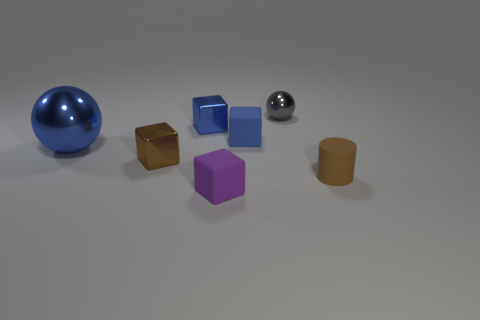There is a matte cube behind the brown matte thing; is its color the same as the big object?
Make the answer very short. Yes. Are there any other things of the same color as the tiny cylinder?
Your answer should be compact. Yes. Does the sphere that is in front of the tiny blue metal thing have the same color as the tiny block that is right of the purple matte block?
Keep it short and to the point. Yes. There is a sphere that is on the left side of the small gray shiny thing; is there a big thing that is on the left side of it?
Offer a terse response. No. There is a small blue rubber object; does it have the same shape as the small blue object that is to the left of the small purple matte cube?
Give a very brief answer. Yes. What is the size of the blue object that is in front of the tiny blue metal object and on the left side of the tiny purple matte block?
Your answer should be very brief. Large. Are there any brown cubes that have the same material as the big sphere?
Your answer should be very brief. Yes. There is a thing that is the same color as the matte cylinder; what size is it?
Give a very brief answer. Small. What is the tiny blue object on the right side of the tiny metal block that is behind the small brown metal cube made of?
Your answer should be very brief. Rubber. What number of large metal objects have the same color as the tiny sphere?
Offer a very short reply. 0. 